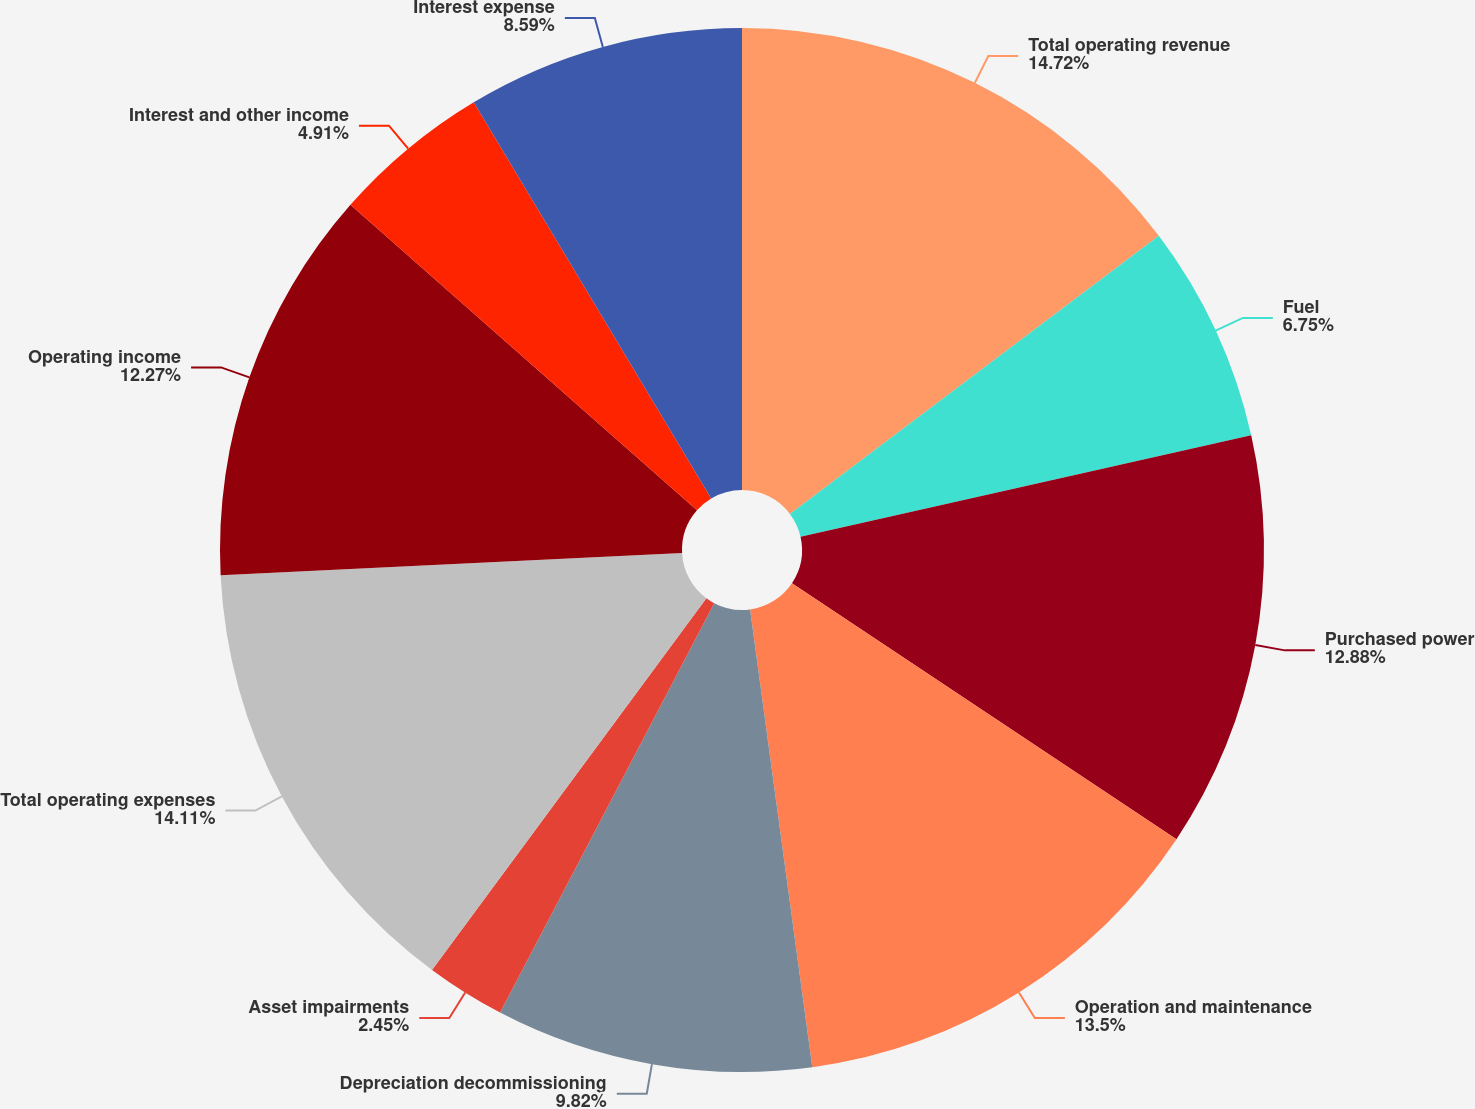Convert chart to OTSL. <chart><loc_0><loc_0><loc_500><loc_500><pie_chart><fcel>Total operating revenue<fcel>Fuel<fcel>Purchased power<fcel>Operation and maintenance<fcel>Depreciation decommissioning<fcel>Asset impairments<fcel>Total operating expenses<fcel>Operating income<fcel>Interest and other income<fcel>Interest expense<nl><fcel>14.72%<fcel>6.75%<fcel>12.88%<fcel>13.5%<fcel>9.82%<fcel>2.45%<fcel>14.11%<fcel>12.27%<fcel>4.91%<fcel>8.59%<nl></chart> 